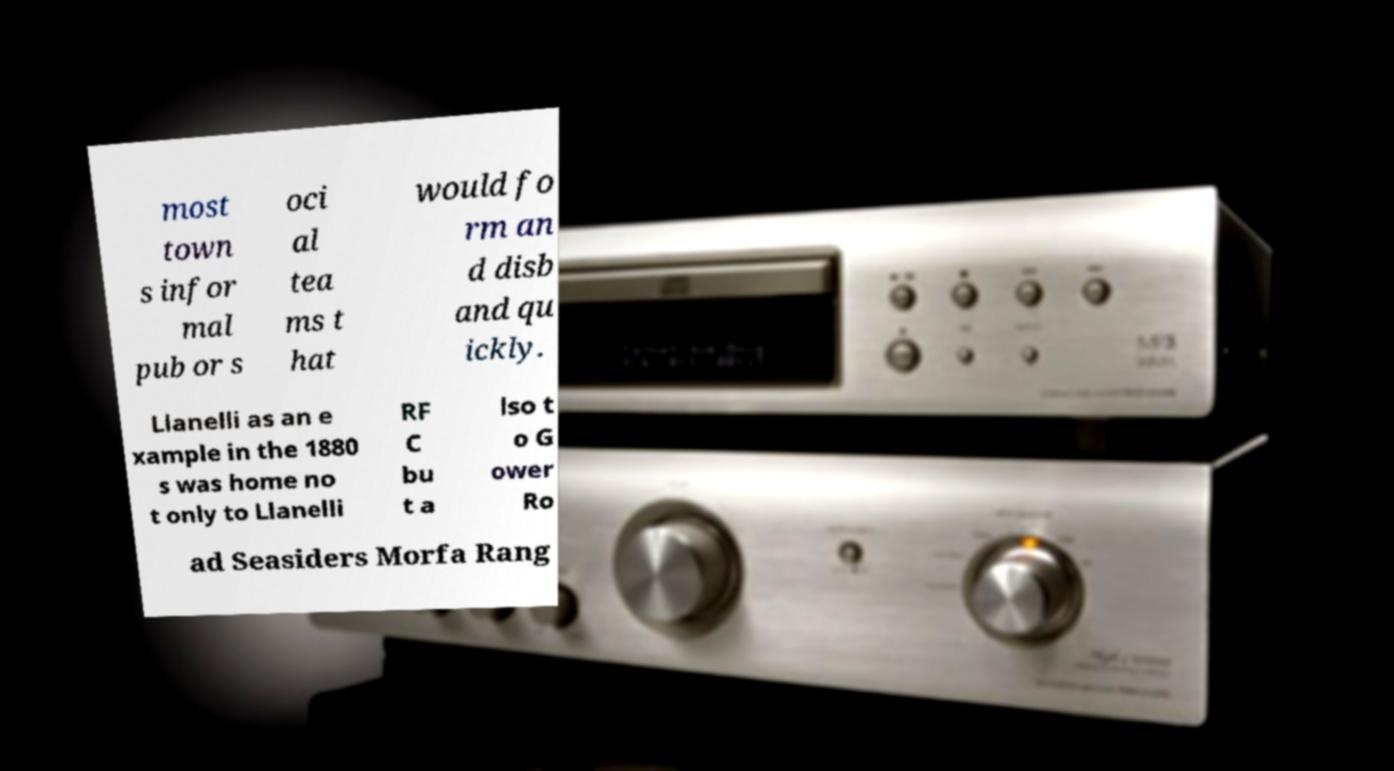Can you read and provide the text displayed in the image?This photo seems to have some interesting text. Can you extract and type it out for me? most town s infor mal pub or s oci al tea ms t hat would fo rm an d disb and qu ickly. Llanelli as an e xample in the 1880 s was home no t only to Llanelli RF C bu t a lso t o G ower Ro ad Seasiders Morfa Rang 